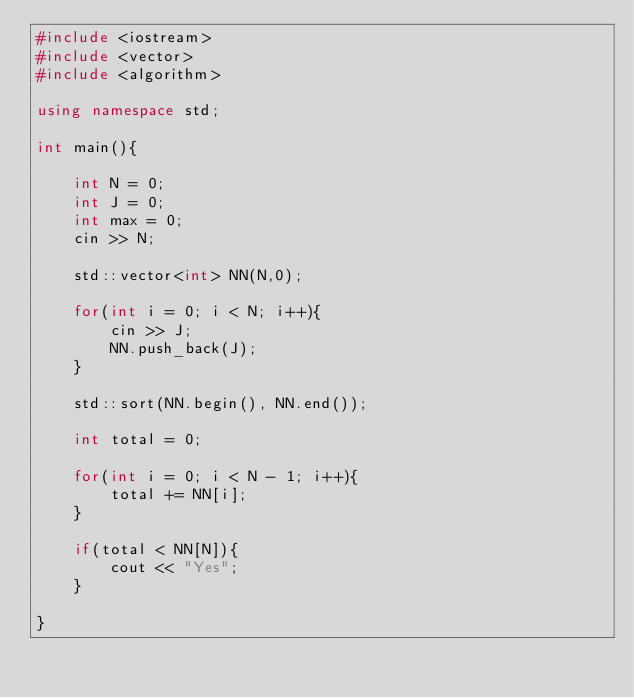Convert code to text. <code><loc_0><loc_0><loc_500><loc_500><_C++_>#include <iostream>
#include <vector>
#include <algorithm>

using namespace std;

int main(){

    int N = 0;
    int J = 0;
    int max = 0;
    cin >> N;

    std::vector<int> NN(N,0);

    for(int i = 0; i < N; i++){
        cin >> J;
        NN.push_back(J);
    }

    std::sort(NN.begin(), NN.end());

    int total = 0;

    for(int i = 0; i < N - 1; i++){
        total += NN[i];
    }

    if(total < NN[N]){
        cout << "Yes";
    }

}</code> 